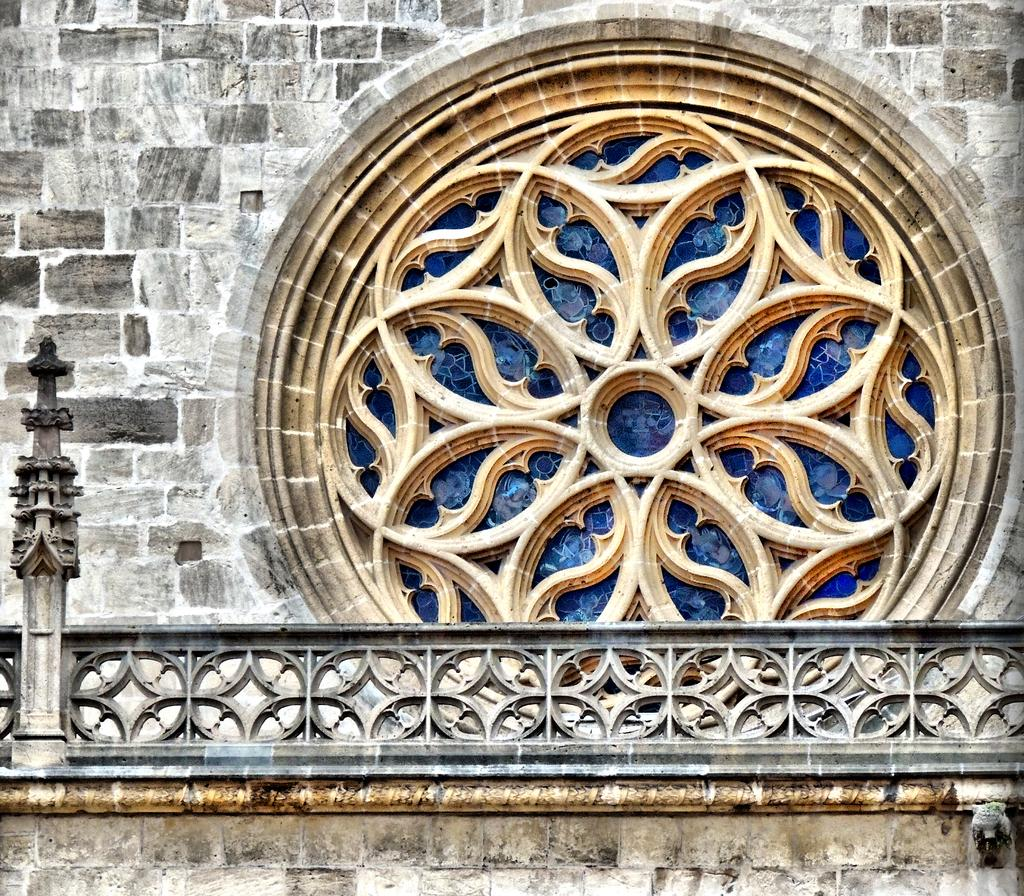What is present on the wall in the image? The wall has a design made of glass in the image. What other objects can be seen in the image? There are grills in the image. Where is the father standing with his jewel in the image? There is no father or jewel present in the image. Is there a bridge visible in the image? No, there is no bridge visible in the image. 